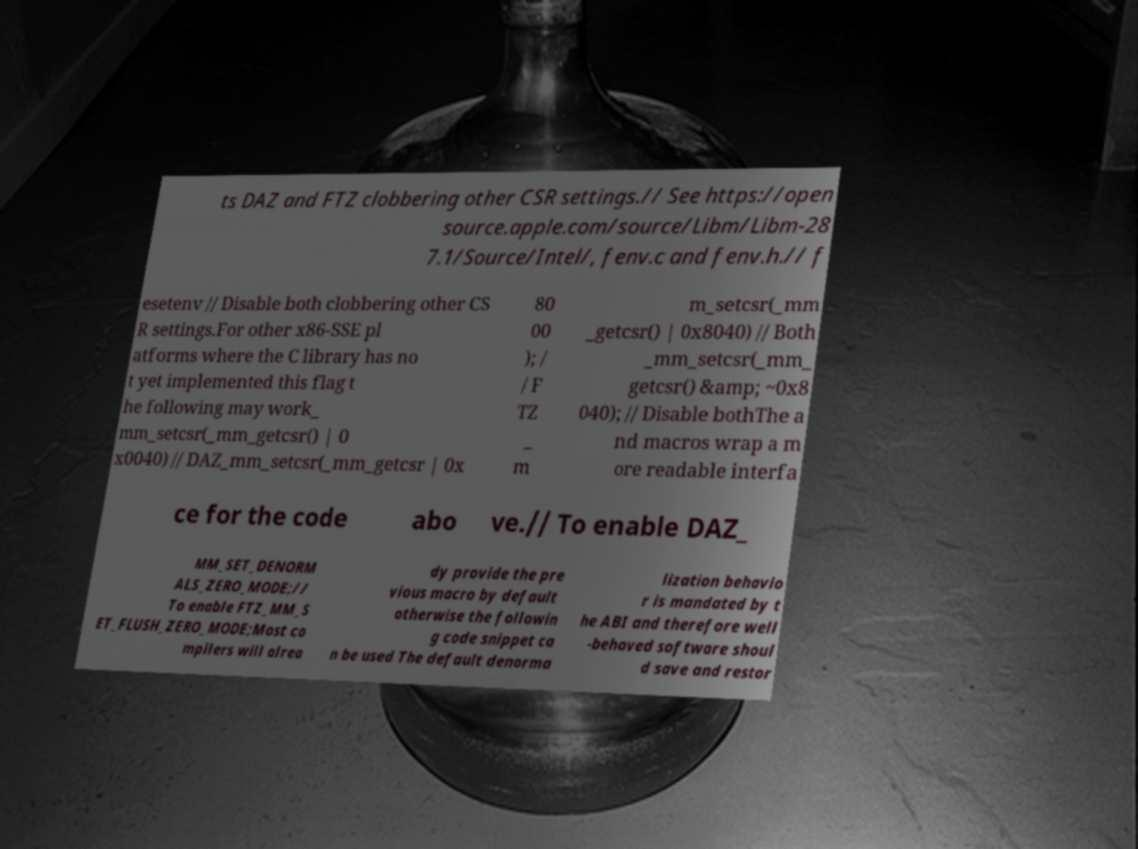Please read and relay the text visible in this image. What does it say? ts DAZ and FTZ clobbering other CSR settings.// See https://open source.apple.com/source/Libm/Libm-28 7.1/Source/Intel/, fenv.c and fenv.h.// f esetenv // Disable both clobbering other CS R settings.For other x86-SSE pl atforms where the C library has no t yet implemented this flag t he following may work_ mm_setcsr(_mm_getcsr() | 0 x0040) // DAZ_mm_setcsr(_mm_getcsr | 0x 80 00 ); / / F TZ _ m m_setcsr(_mm _getcsr() | 0x8040) // Both _mm_setcsr(_mm_ getcsr() &amp; ~0x8 040); // Disable bothThe a nd macros wrap a m ore readable interfa ce for the code abo ve.// To enable DAZ_ MM_SET_DENORM ALS_ZERO_MODE;// To enable FTZ_MM_S ET_FLUSH_ZERO_MODE;Most co mpilers will alrea dy provide the pre vious macro by default otherwise the followin g code snippet ca n be used The default denorma lization behavio r is mandated by t he ABI and therefore well -behaved software shoul d save and restor 